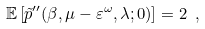Convert formula to latex. <formula><loc_0><loc_0><loc_500><loc_500>\mathbb { E } \left [ { \tilde { p } } ^ { \prime \prime } ( \beta , \mu - \varepsilon ^ { \omega } , \lambda ; 0 ) \right ] = 2 \ ,</formula> 